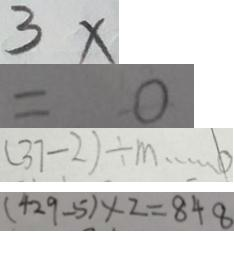<formula> <loc_0><loc_0><loc_500><loc_500>3 x 
 = 0 
 ( 3 7 - 2 ) \div m \cdots 0 
 ( 4 2 9 - 5 ) \times 2 = 8 4 8</formula> 